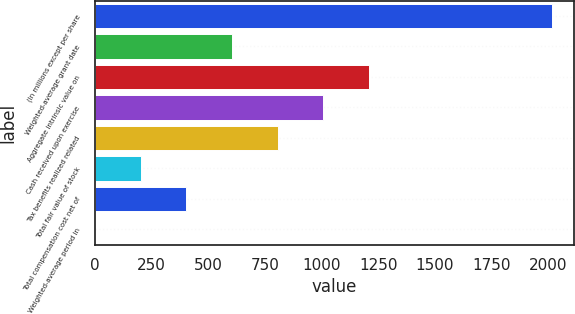Convert chart to OTSL. <chart><loc_0><loc_0><loc_500><loc_500><bar_chart><fcel>(In millions except per share<fcel>Weighted-average grant date<fcel>Aggregate intrinsic value on<fcel>Cash received upon exercise<fcel>Tax benefits realized related<fcel>Total fair value of stock<fcel>Total compensation cost net of<fcel>Weighted-average period in<nl><fcel>2015<fcel>605.9<fcel>1209.8<fcel>1008.5<fcel>807.2<fcel>203.3<fcel>404.6<fcel>2<nl></chart> 